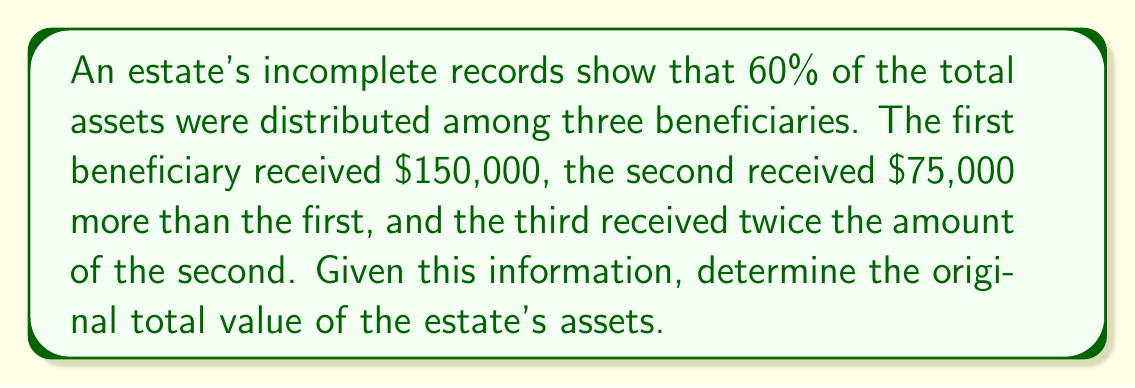Provide a solution to this math problem. Let's approach this step-by-step:

1) Let x be the amount the first beneficiary received. We know this is $150,000.
   $x = 150,000$

2) The second beneficiary received $75,000 more than the first:
   $y = x + 75,000 = 150,000 + 75,000 = 225,000$

3) The third beneficiary received twice the amount of the second:
   $z = 2y = 2(225,000) = 450,000$

4) The total distributed to these three beneficiaries is:
   $T = x + y + z = 150,000 + 225,000 + 450,000 = 825,000$

5) We're told that this distribution represents 60% of the total assets. Let's call the total assets A. We can set up the equation:
   $825,000 = 0.60A$

6) Solving for A:
   $A = \frac{825,000}{0.60} = 1,375,000$

Therefore, the original total value of the estate's assets was $1,375,000.
Answer: $1,375,000 